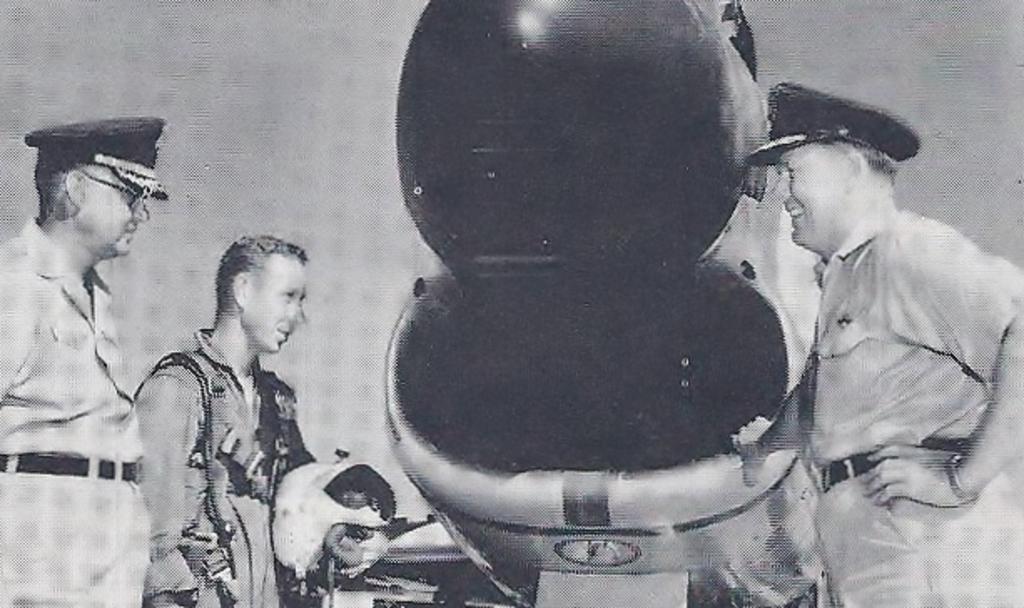Please provide a concise description of this image. This is a black and white image. In this image, on the right side, we can see a man standing and holding an electronic machine in his hand. On the left side, we can also see two people standing. In the background, we can see white color. In the middle of the image, we can see an electronic machine. 